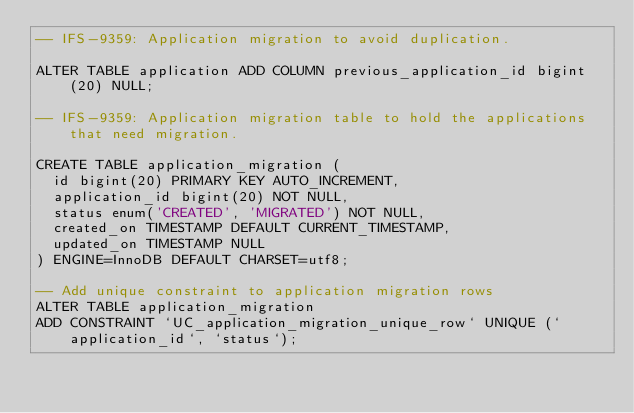Convert code to text. <code><loc_0><loc_0><loc_500><loc_500><_SQL_>-- IFS-9359: Application migration to avoid duplication.

ALTER TABLE application ADD COLUMN previous_application_id bigint(20) NULL;

-- IFS-9359: Application migration table to hold the applications that need migration.

CREATE TABLE application_migration (
  id bigint(20) PRIMARY KEY AUTO_INCREMENT,
  application_id bigint(20) NOT NULL,
  status enum('CREATED', 'MIGRATED') NOT NULL,
  created_on TIMESTAMP DEFAULT CURRENT_TIMESTAMP,
  updated_on TIMESTAMP NULL
) ENGINE=InnoDB DEFAULT CHARSET=utf8;

-- Add unique constraint to application migration rows
ALTER TABLE application_migration
ADD CONSTRAINT `UC_application_migration_unique_row` UNIQUE (`application_id`, `status`);</code> 